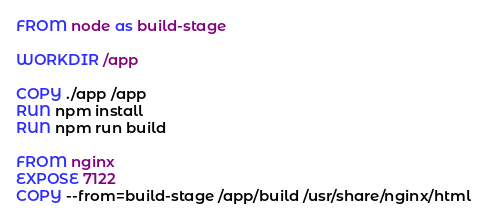<code> <loc_0><loc_0><loc_500><loc_500><_Dockerfile_>FROM node as build-stage

WORKDIR /app

COPY ./app /app
RUN npm install
RUN npm run build

FROM nginx
EXPOSE 7122
COPY --from=build-stage /app/build /usr/share/nginx/html
</code> 